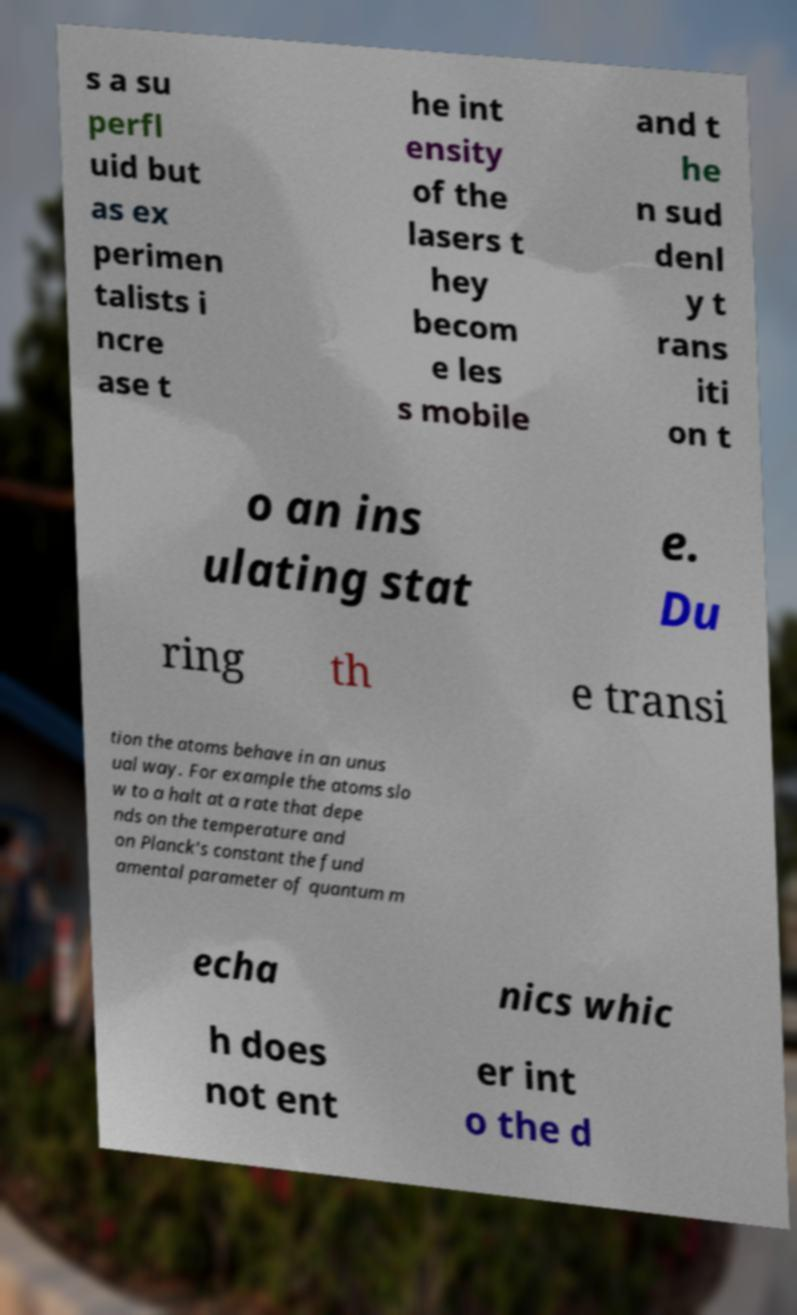For documentation purposes, I need the text within this image transcribed. Could you provide that? s a su perfl uid but as ex perimen talists i ncre ase t he int ensity of the lasers t hey becom e les s mobile and t he n sud denl y t rans iti on t o an ins ulating stat e. Du ring th e transi tion the atoms behave in an unus ual way. For example the atoms slo w to a halt at a rate that depe nds on the temperature and on Planck's constant the fund amental parameter of quantum m echa nics whic h does not ent er int o the d 